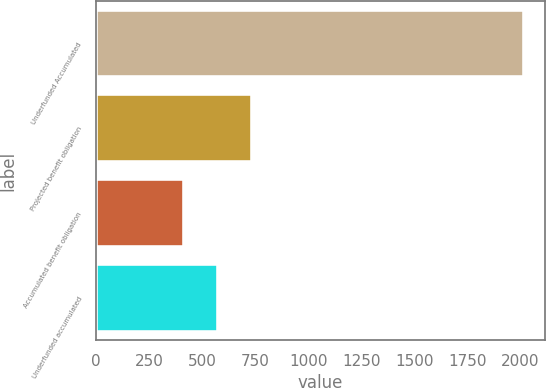<chart> <loc_0><loc_0><loc_500><loc_500><bar_chart><fcel>Underfunded Accumulated<fcel>Projected benefit obligation<fcel>Accumulated benefit obligation<fcel>Underfunded accumulated<nl><fcel>2016<fcel>732.8<fcel>412<fcel>572.4<nl></chart> 